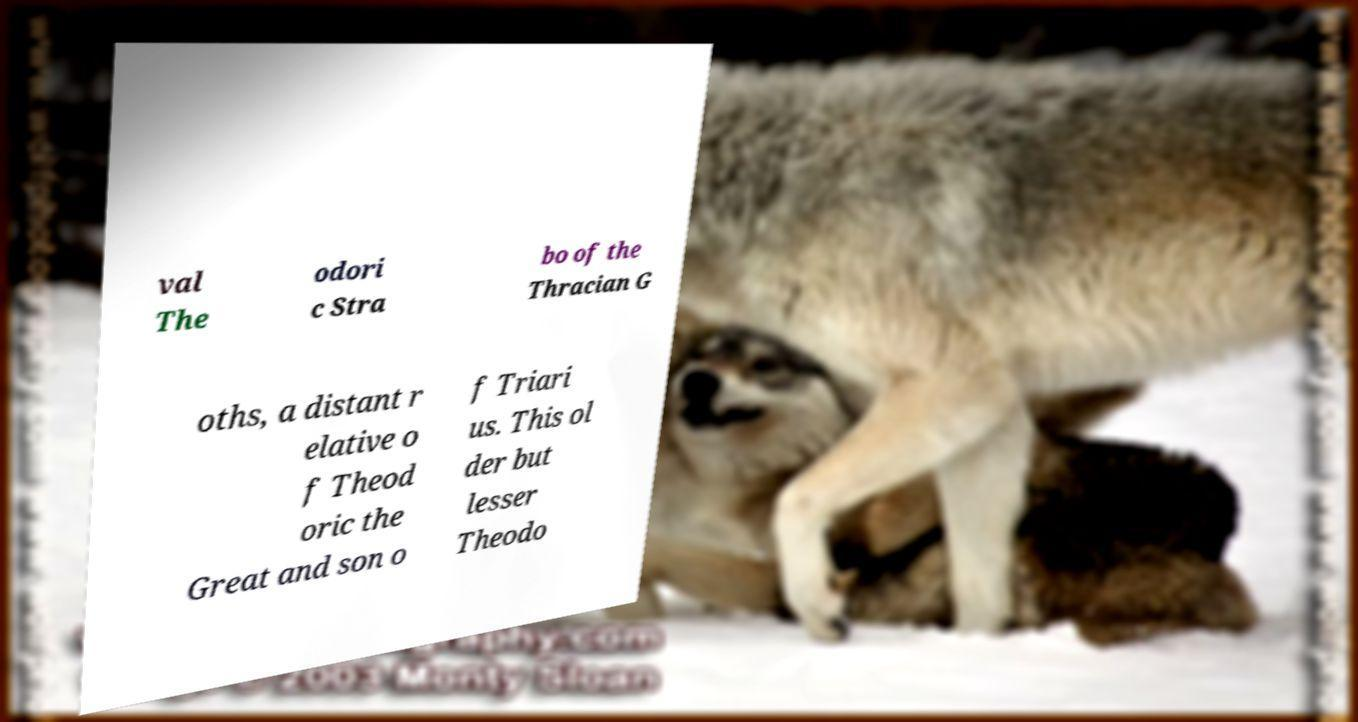Could you assist in decoding the text presented in this image and type it out clearly? val The odori c Stra bo of the Thracian G oths, a distant r elative o f Theod oric the Great and son o f Triari us. This ol der but lesser Theodo 